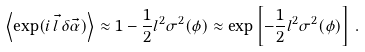Convert formula to latex. <formula><loc_0><loc_0><loc_500><loc_500>\left \langle \exp ( i \, \vec { l } \, \delta \vec { \alpha } ) \right \rangle \approx 1 - \frac { 1 } { 2 } l ^ { 2 } \sigma ^ { 2 } ( \phi ) \approx \exp \left [ - \frac { 1 } { 2 } l ^ { 2 } \sigma ^ { 2 } ( \phi ) \right ] \, .</formula> 